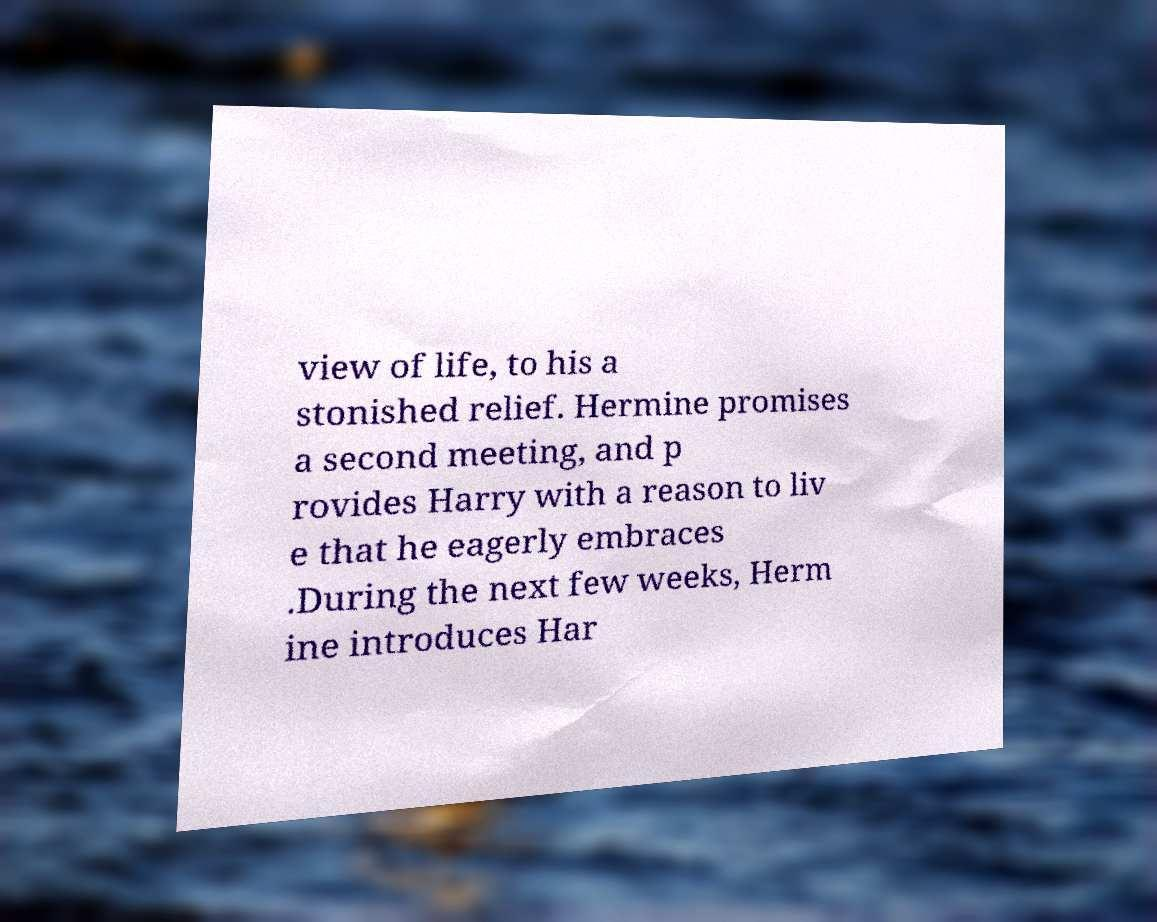Please read and relay the text visible in this image. What does it say? view of life, to his a stonished relief. Hermine promises a second meeting, and p rovides Harry with a reason to liv e that he eagerly embraces .During the next few weeks, Herm ine introduces Har 